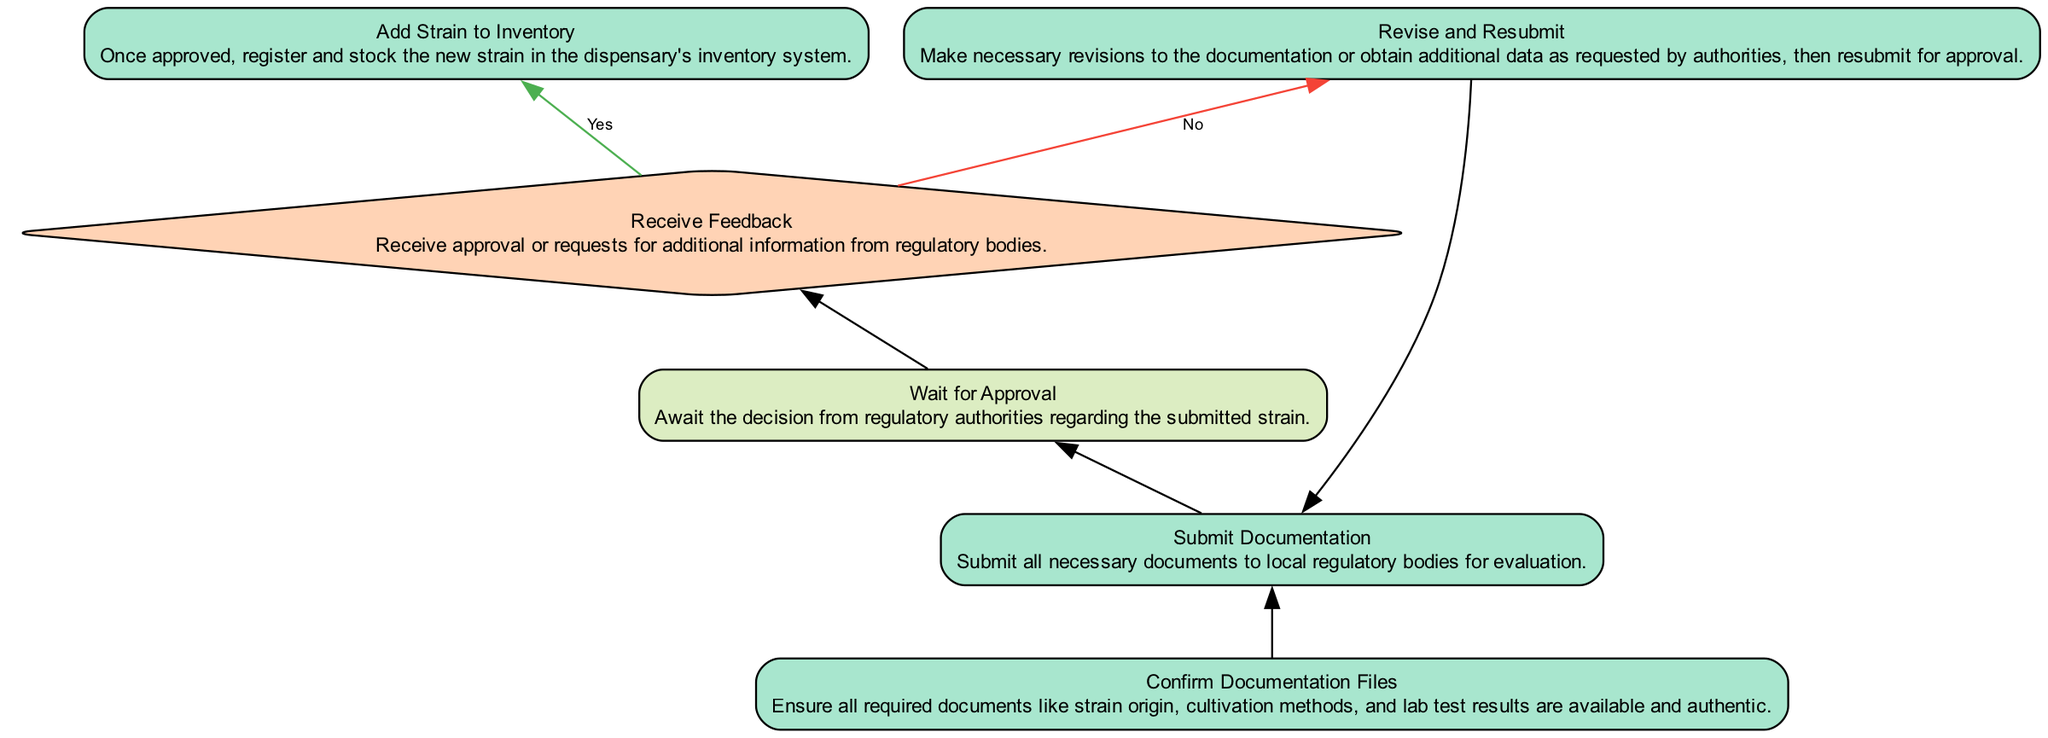What is the first step in the compliance process? The first step is "Confirm Documentation Files" which ensures all required documents are available and authentic.
Answer: Confirm Documentation Files What happens after "Submit Documentation"? After submitting documentation, the next step is "Wait for Approval," where the process delays until a decision from regulatory authorities is received.
Answer: Wait for Approval How many decisions are present in the diagram? There is one decision node labeled "Receive Feedback" which determines whether to add the strain to inventory or to revise and resubmit.
Answer: One What action is taken if the feedback is negative? If the feedback is negative, the process will move to "Revise and Resubmit," where necessary revisions are made to documentation before resubmitting.
Answer: Revise and Resubmit What type of node is "Receive Feedback"? "Receive Feedback" is a decision node. This node has two potential outcomes based on the approval status received from regulatory bodies.
Answer: Decision After receiving positive feedback, what is the subsequent process? Upon receiving positive feedback, the next action is "Add Strain to Inventory," registering the new strain in the dispensary's inventory system.
Answer: Add Strain to Inventory If the strain documentation is not approved, what process follows? If the strain documentation is not approved, the process requires "Revise and Resubmit" to correct the issues before proceeding anew with the submission.
Answer: Revise and Resubmit What color is used for process nodes? Process nodes are filled with a color code that corresponds to light green, which visually differentiates them from delay and decision nodes in the flowchart.
Answer: Light green What is the final action listed in the compliance process? The final action listed is "Add Strain to Inventory," which means that the strain gets registered and stocked after receiving approval.
Answer: Add Strain to Inventory 